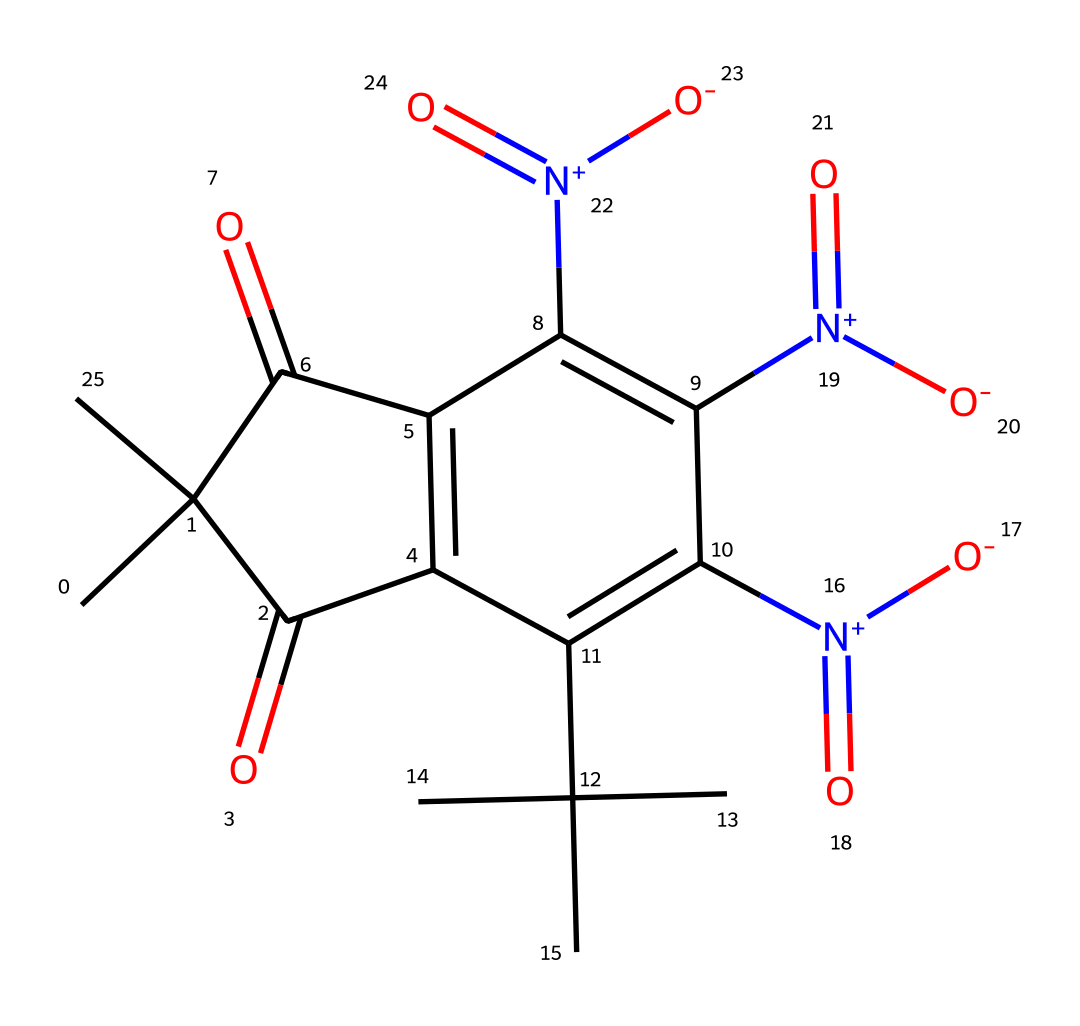What is the molecular formula of synthetic musk ketone? By analyzing the SMILES representation, we can count the atoms present in the chemical structure: there are 15 carbons (C), 18 hydrogens (H), 4 nitrogens (N), and 5 oxygens (O). Therefore, the molecular formula can be constructed as C15H18N4O5.
Answer: C15H18N4O5 How many carbon atoms are present in synthetic musk ketone? From the SMILES representation, we identify and count the 'C' characters, which gives us a total of 15 carbon atoms.
Answer: 15 What functional groups are present in synthetic musk ketone? The structure has several functional groups identified by looking for specific atoms or structures: the carbonyl groups (=O) and nitro groups (N(=O)=O) are observable in the chemical.
Answer: carbonyl and nitro What properties might synthetic musk ketone provide in fragrances? Synthetic musk ketone, as a fixative, helps to stabilize the fragrance and prolong its scent. This conclusion is drawn from its structural complexity and interactions with other fragrance components that allow it to act effectively in formulations.
Answer: fixative Is synthetic musk ketone considered a natural or synthetic fragrance compound? The description "synthetic musk ketone" indicates that it is artificially manufactured, contrasting it with naturally sourced fragrances.
Answer: synthetic What is the role of the nitrogen atoms in the fragrance properties of synthetic musk ketone? Nitrogen atoms, particularly as part of nitro groups, typically enhance odor profiles in fragrance compounds. Their presence can contribute to certain scent characteristics, making the compound more appealing.
Answer: enhance What impact do structural modifications have on the fragrance characteristics of synthetic musk ketone? Structural modifications, such as changing the positioning or nature of functional groups, can significantly influence olfactory properties and volatility of the musk compound, making it more or less effective in various formulations.
Answer: influence olfactory properties 